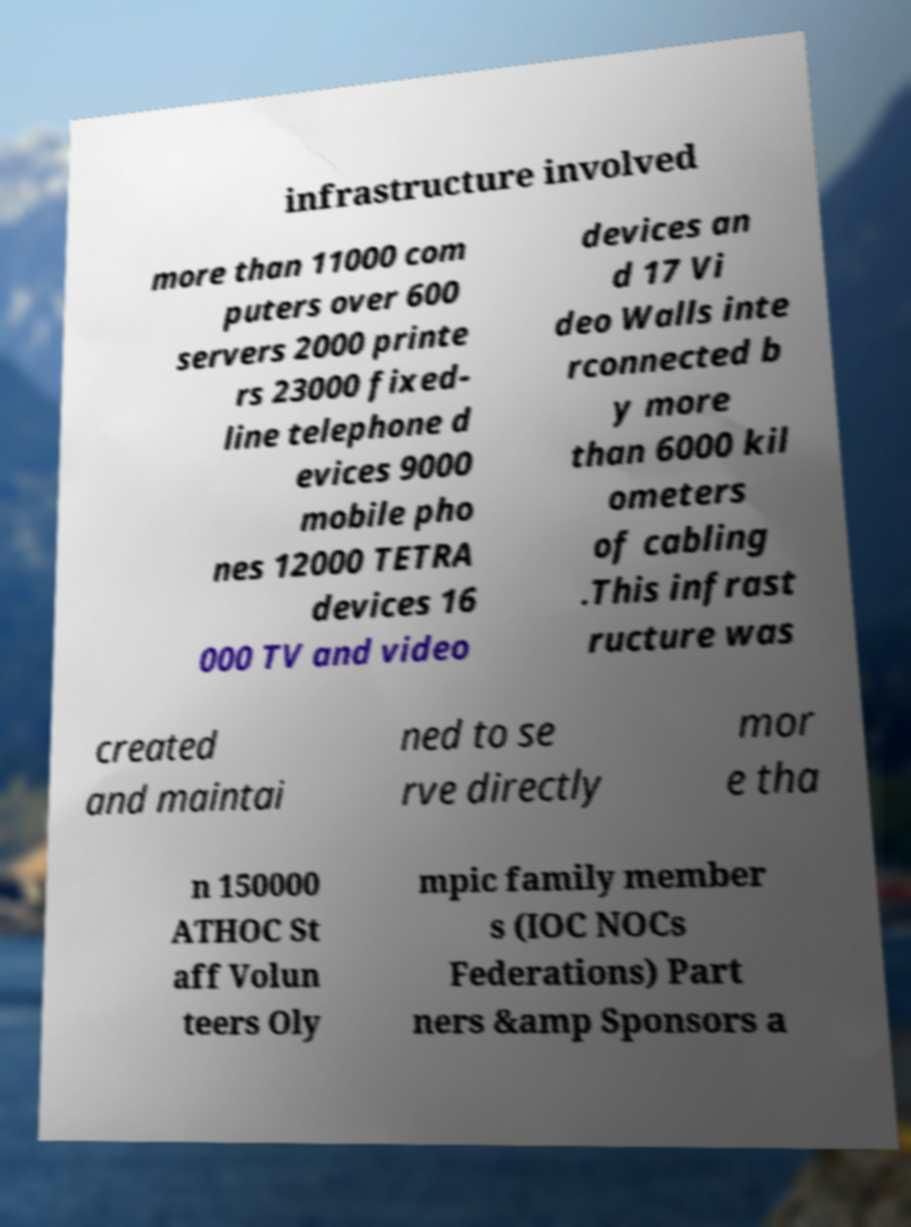Could you extract and type out the text from this image? infrastructure involved more than 11000 com puters over 600 servers 2000 printe rs 23000 fixed- line telephone d evices 9000 mobile pho nes 12000 TETRA devices 16 000 TV and video devices an d 17 Vi deo Walls inte rconnected b y more than 6000 kil ometers of cabling .This infrast ructure was created and maintai ned to se rve directly mor e tha n 150000 ATHOC St aff Volun teers Oly mpic family member s (IOC NOCs Federations) Part ners &amp Sponsors a 